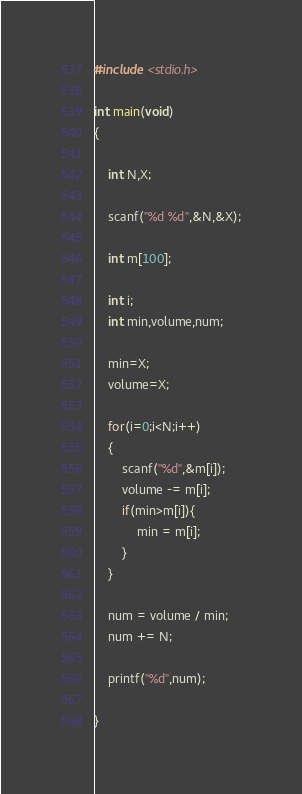Convert code to text. <code><loc_0><loc_0><loc_500><loc_500><_C_>#include <stdio.h>

int main(void)
{

	int N,X;
	
	scanf("%d %d",&N,&X);
	
	int m[100];
	
	int i;
	int min,volume,num;
	
	min=X;
	volume=X;
	
	for(i=0;i<N;i++)
	{
		scanf("%d",&m[i]);
		volume -= m[i];
		if(min>m[i]){
			min = m[i];
		}
	}
	
	num = volume / min;
	num += N;

	printf("%d",num);

}
</code> 